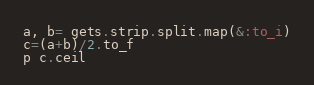<code> <loc_0><loc_0><loc_500><loc_500><_Ruby_>a, b= gets.strip.split.map(&:to_i)
c=(a+b)/2.to_f
p c.ceil
</code> 